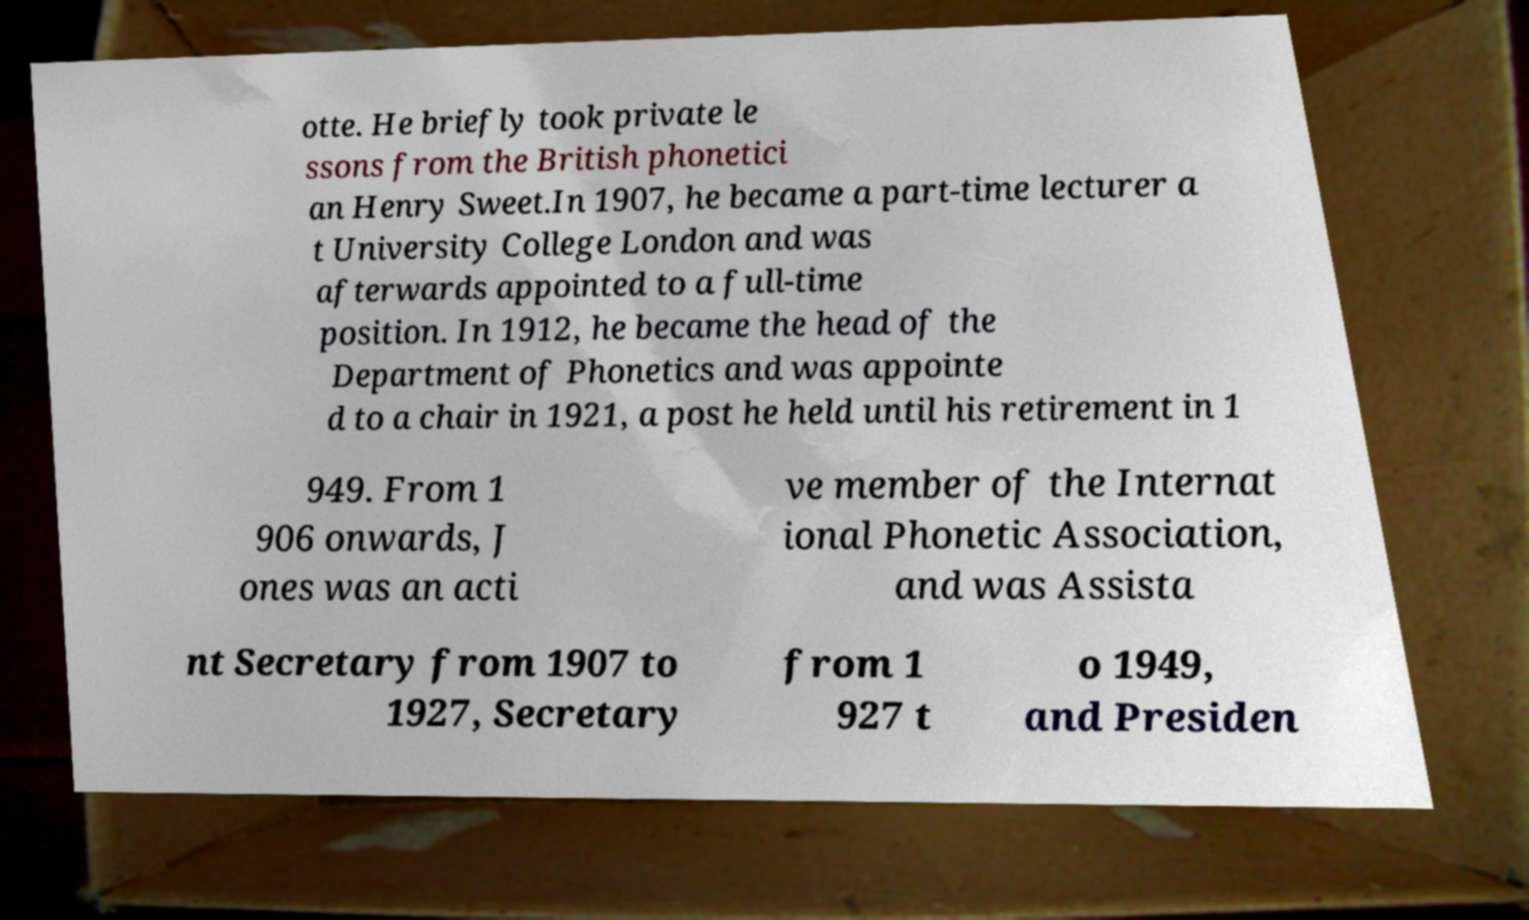Please read and relay the text visible in this image. What does it say? otte. He briefly took private le ssons from the British phonetici an Henry Sweet.In 1907, he became a part-time lecturer a t University College London and was afterwards appointed to a full-time position. In 1912, he became the head of the Department of Phonetics and was appointe d to a chair in 1921, a post he held until his retirement in 1 949. From 1 906 onwards, J ones was an acti ve member of the Internat ional Phonetic Association, and was Assista nt Secretary from 1907 to 1927, Secretary from 1 927 t o 1949, and Presiden 